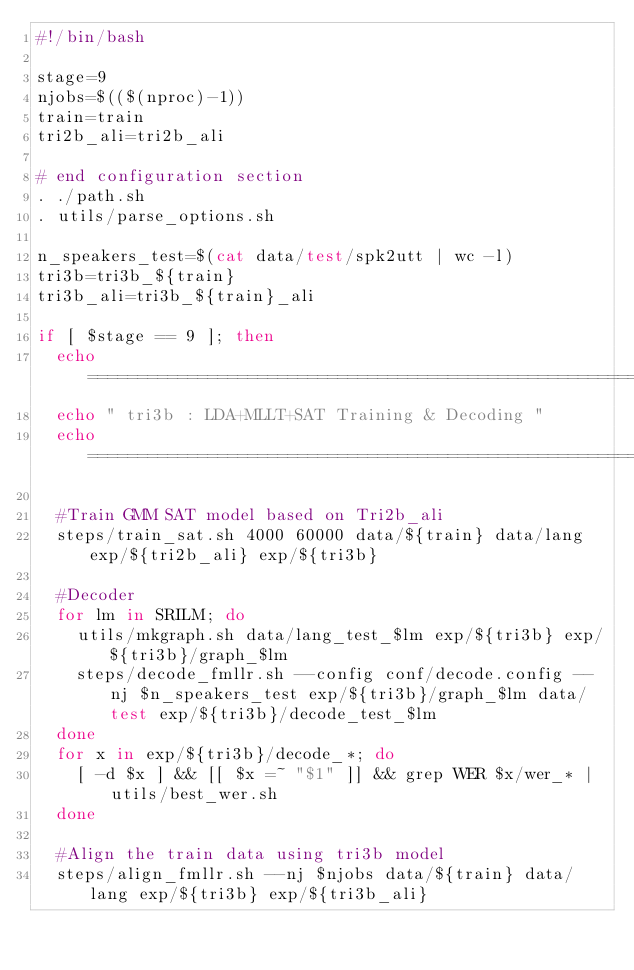Convert code to text. <code><loc_0><loc_0><loc_500><loc_500><_Bash_>#!/bin/bash

stage=9
njobs=$(($(nproc)-1))
train=train
tri2b_ali=tri2b_ali

# end configuration section
. ./path.sh
. utils/parse_options.sh

n_speakers_test=$(cat data/test/spk2utt | wc -l)
tri3b=tri3b_${train}
tri3b_ali=tri3b_${train}_ali

if [ $stage == 9 ]; then
  echo ============================================================================
  echo " tri3b : LDA+MLLT+SAT Training & Decoding "
  echo ============================================================================
  
  #Train GMM SAT model based on Tri2b_ali
  steps/train_sat.sh 4000 60000 data/${train} data/lang exp/${tri2b_ali} exp/${tri3b}

  #Decoder
  for lm in SRILM; do
    utils/mkgraph.sh data/lang_test_$lm exp/${tri3b} exp/${tri3b}/graph_$lm
    steps/decode_fmllr.sh --config conf/decode.config --nj $n_speakers_test exp/${tri3b}/graph_$lm data/test exp/${tri3b}/decode_test_$lm
  done
  for x in exp/${tri3b}/decode_*; do
    [ -d $x ] && [[ $x =~ "$1" ]] && grep WER $x/wer_* | utils/best_wer.sh
  done

  #Align the train data using tri3b model
  steps/align_fmllr.sh --nj $njobs data/${train} data/lang exp/${tri3b} exp/${tri3b_ali}</code> 